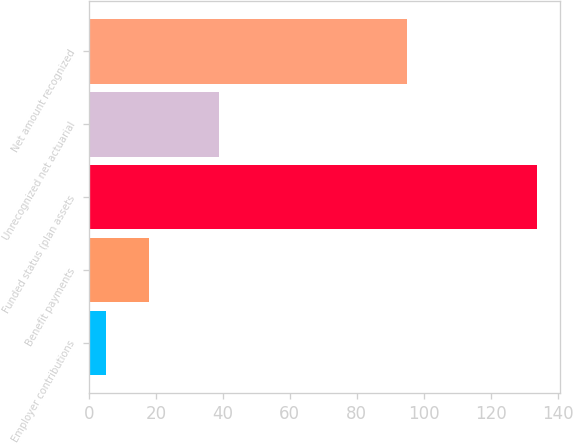Convert chart to OTSL. <chart><loc_0><loc_0><loc_500><loc_500><bar_chart><fcel>Employer contributions<fcel>Benefit payments<fcel>Funded status (plan assets<fcel>Unrecognized net actuarial<fcel>Net amount recognized<nl><fcel>5<fcel>17.9<fcel>134<fcel>39<fcel>95<nl></chart> 